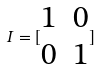<formula> <loc_0><loc_0><loc_500><loc_500>I = [ \begin{matrix} 1 & 0 \\ 0 & 1 \end{matrix} ]</formula> 